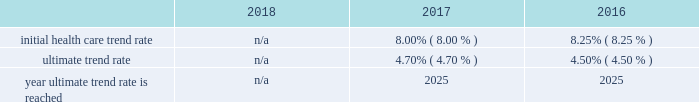Marathon oil corporation notes to consolidated financial statements expected long-term return on plan assets 2013 the expected long-term return on plan assets assumption for our u.s .
Funded plan is determined based on an asset rate-of-return modeling tool developed by a third-party investment group which utilizes underlying assumptions based on actual returns by asset category and inflation and takes into account our u.s .
Pension plan 2019s asset allocation .
To determine the expected long-term return on plan assets assumption for our international plans , we consider the current level of expected returns on risk-free investments ( primarily government bonds ) , the historical levels of the risk premiums associated with the other applicable asset categories and the expectations for future returns of each asset class .
The expected return for each asset category is then weighted based on the actual asset allocation to develop the overall expected long-term return on plan assets assumption .
Assumed weighted average health care cost trend rates .
N/a all retiree medical subsidies are frozen as of january 1 , 2019 .
Employer provided subsidies for post-65 retiree health care coverage were frozen effective january 1 , 2017 at january 1 , 2016 established amount levels .
Company contributions are funded to a health reimbursement account on the retiree 2019s behalf to subsidize the retiree 2019s cost of obtaining health care benefits through a private exchange ( the 201cpost-65 retiree health benefits 201d ) .
Therefore , a 1% ( 1 % ) change in health care cost trend rates would not have a material impact on either the service and interest cost components and the postretirement benefit obligations .
In the fourth quarter of 2018 , we terminated the post-65 retiree health benefits effective as of december 31 , 2020 .
The post-65 retiree health benefits will no longer be provided after that date .
In addition , the pre-65 retiree medical coverage subsidy has been frozen as of january 1 , 2019 , and the ability for retirees to opt in and out of this coverage , as well as pre-65 retiree dental and vision coverage , has also been eliminated .
Retirees must enroll in connection with retirement for such coverage , or they lose eligibility .
These plan changes reduced our retiree medical benefit obligation by approximately $ 99 million .
Plan investment policies and strategies 2013 the investment policies for our u.s .
And international pension plan assets reflect the funded status of the plans and expectations regarding our future ability to make further contributions .
Long-term investment goals are to : ( 1 ) manage the assets in accordance with applicable legal requirements ; ( 2 ) produce investment returns which meet or exceed the rates of return achievable in the capital markets while maintaining the risk parameters set by the plan's investment committees and protecting the assets from any erosion of purchasing power ; and ( 3 ) position the portfolios with a long-term risk/ return orientation .
Investment performance and risk is measured and monitored on an ongoing basis through quarterly investment meetings and periodic asset and liability studies .
U.s .
Plan 2013 the plan 2019s current targeted asset allocation is comprised of 55% ( 55 % ) equity securities and 45% ( 45 % ) other fixed income securities .
Over time , as the plan 2019s funded ratio ( as defined by the investment policy ) improves , in order to reduce volatility in returns and to better match the plan 2019s liabilities , the allocation to equity securities will decrease while the amount allocated to fixed income securities will increase .
The plan's assets are managed by a third-party investment manager .
International plan 2013 our international plan's target asset allocation is comprised of 55% ( 55 % ) equity securities and 45% ( 45 % ) fixed income securities .
The plan assets are invested in ten separate portfolios , mainly pooled fund vehicles , managed by several professional investment managers whose performance is measured independently by a third-party asset servicing consulting fair value measurements 2013 plan assets are measured at fair value .
The following provides a description of the valuation techniques employed for each major plan asset class at december 31 , 2018 and 2017 .
Cash and cash equivalents 2013 cash and cash equivalents are valued using a market approach and are considered level 1 .
Equity securities 2013 investments in common stock are valued using a market approach at the closing price reported in an active market and are therefore considered level 1 .
Private equity investments include interests in limited partnerships which are valued based on the sum of the estimated fair values of the investments held by each partnership , determined using a combination of market , income and cost approaches , plus working capital , adjusted for liabilities , currency translation and estimated performance incentives .
These private equity investments are considered level 3 .
Investments in pooled funds are valued using a market approach , these various funds consist of equity with underlying investments held in u.s .
And non-u.s .
Securities .
The pooled funds are benchmarked against a relative public index and are considered level 2. .
What was the difference in the initial health care trend rate and the ultimate trend rate in 2017? 
Computations: (8.00% - 4.70%)
Answer: 0.033. 